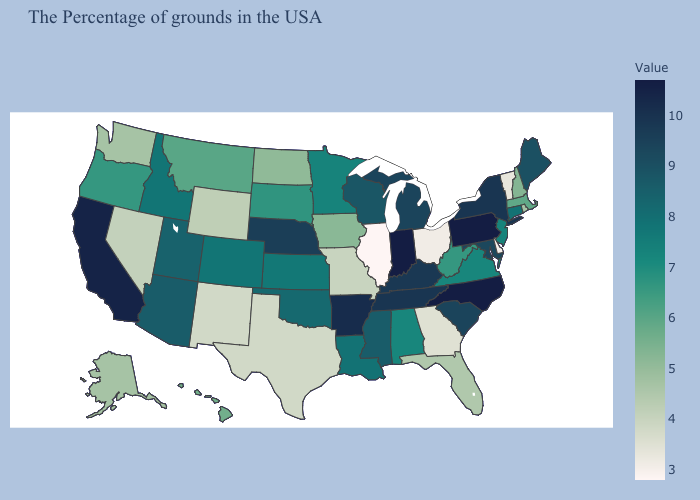Does Illinois have the lowest value in the USA?
Be succinct. Yes. Among the states that border Montana , does North Dakota have the lowest value?
Quick response, please. No. Among the states that border Rhode Island , does Connecticut have the highest value?
Give a very brief answer. Yes. Which states have the lowest value in the USA?
Keep it brief. Illinois. Does Delaware have the lowest value in the South?
Quick response, please. Yes. Which states have the lowest value in the USA?
Short answer required. Illinois. Which states have the lowest value in the USA?
Give a very brief answer. Illinois. Does Arizona have a higher value than Indiana?
Be succinct. No. 